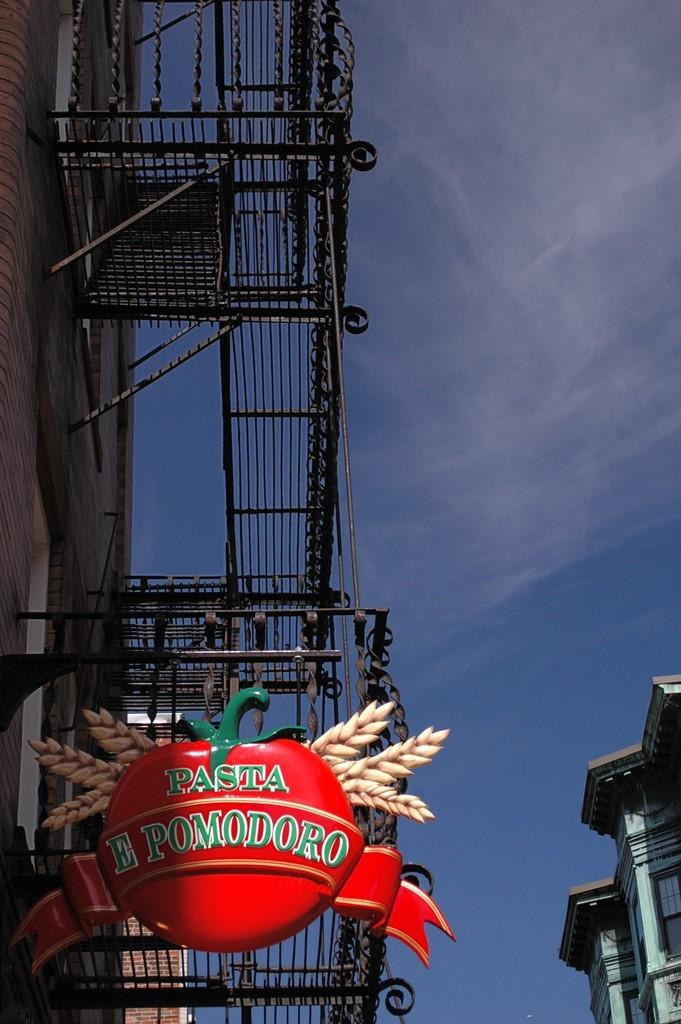Describe this image in one or two sentences. In this image we can able to see a blue sky and there is a building over here, we can able to see a stair case, and we can able to see a board which consists of a name called pasta e pomodoro and this board is made like tomato and corn leaves and there is another building here. 